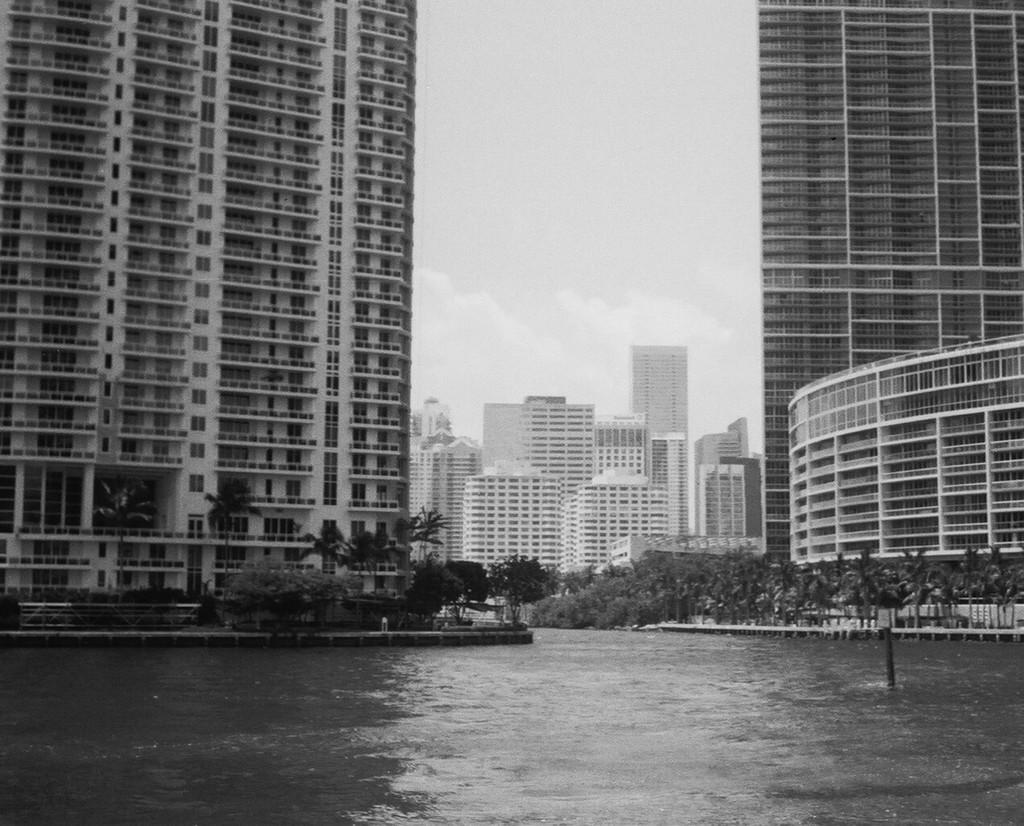What is the primary element visible in the image? There is water in the image. What object can be seen in the water? There is a pole in the image. What can be seen in the distance behind the water? There are buildings and trees in the background of the image. What part of the natural environment is visible in the image? The sky is visible in the background of the image. What type of sugar is being used to create the ghost in the image? There is no ghost or sugar present in the image. What is the zinc content of the water in the image? The zinc content of the water cannot be determined from the image. 